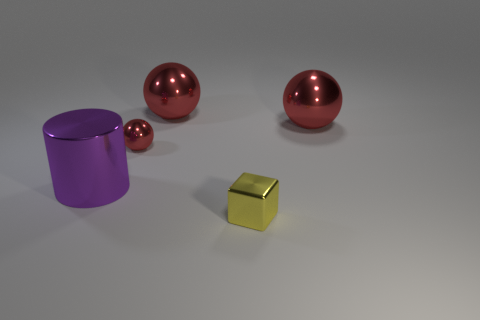How are the objects arranged in the image? The objects are spread across a smooth surface with ample space between them. There is one yellow cube towards the front, while two red spheres and a violet cylinder are positioned further back, creating a visually engaging composition with variation in shape and color. 